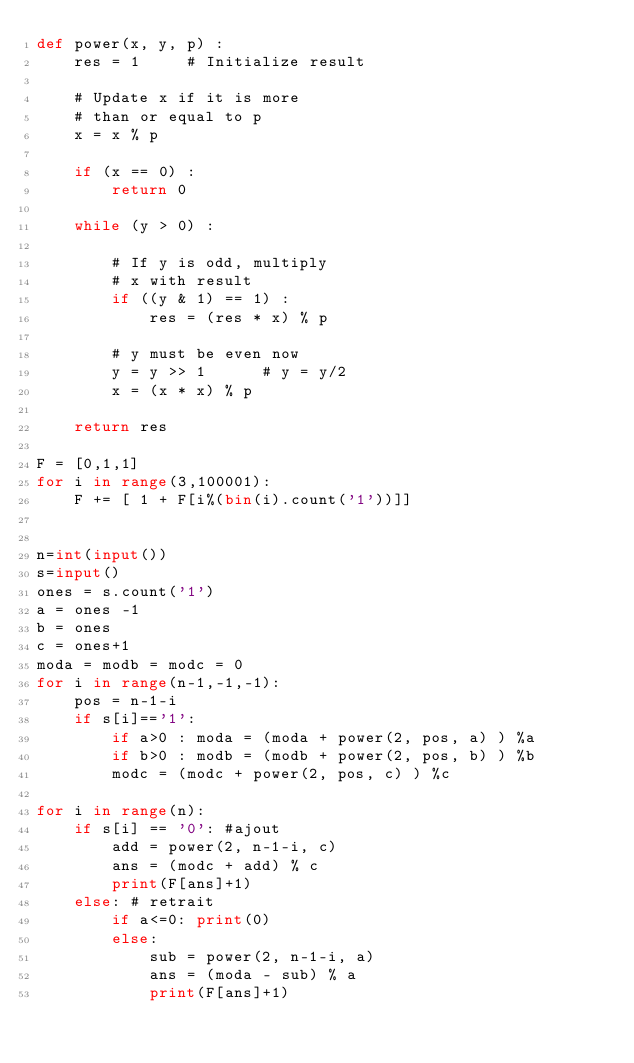Convert code to text. <code><loc_0><loc_0><loc_500><loc_500><_Python_>def power(x, y, p) : 
    res = 1     # Initialize result 
  
    # Update x if it is more 
    # than or equal to p 
    x = x % p  
      
    if (x == 0) : 
        return 0
  
    while (y > 0) : 
          
        # If y is odd, multiply 
        # x with result 
        if ((y & 1) == 1) : 
            res = (res * x) % p 
  
        # y must be even now 
        y = y >> 1      # y = y/2 
        x = (x * x) % p 
          
    return res  

F = [0,1,1]
for i in range(3,100001):
	F += [ 1 + F[i%(bin(i).count('1'))]]
	

n=int(input())
s=input()
ones = s.count('1')
a = ones -1
b = ones
c = ones+1
moda = modb = modc = 0
for i in range(n-1,-1,-1):
	pos = n-1-i
	if s[i]=='1':
		if a>0 : moda = (moda + power(2, pos, a) ) %a
		if b>0 : modb = (modb + power(2, pos, b) ) %b
		modc = (modc + power(2, pos, c) ) %c

for i in range(n):
	if s[i] == '0': #ajout
		add = power(2, n-1-i, c)
		ans = (modc + add) % c
		print(F[ans]+1)
	else: # retrait
		if a<=0: print(0)
		else:
			sub = power(2, n-1-i, a)
			ans = (moda - sub) % a
			print(F[ans]+1)
</code> 